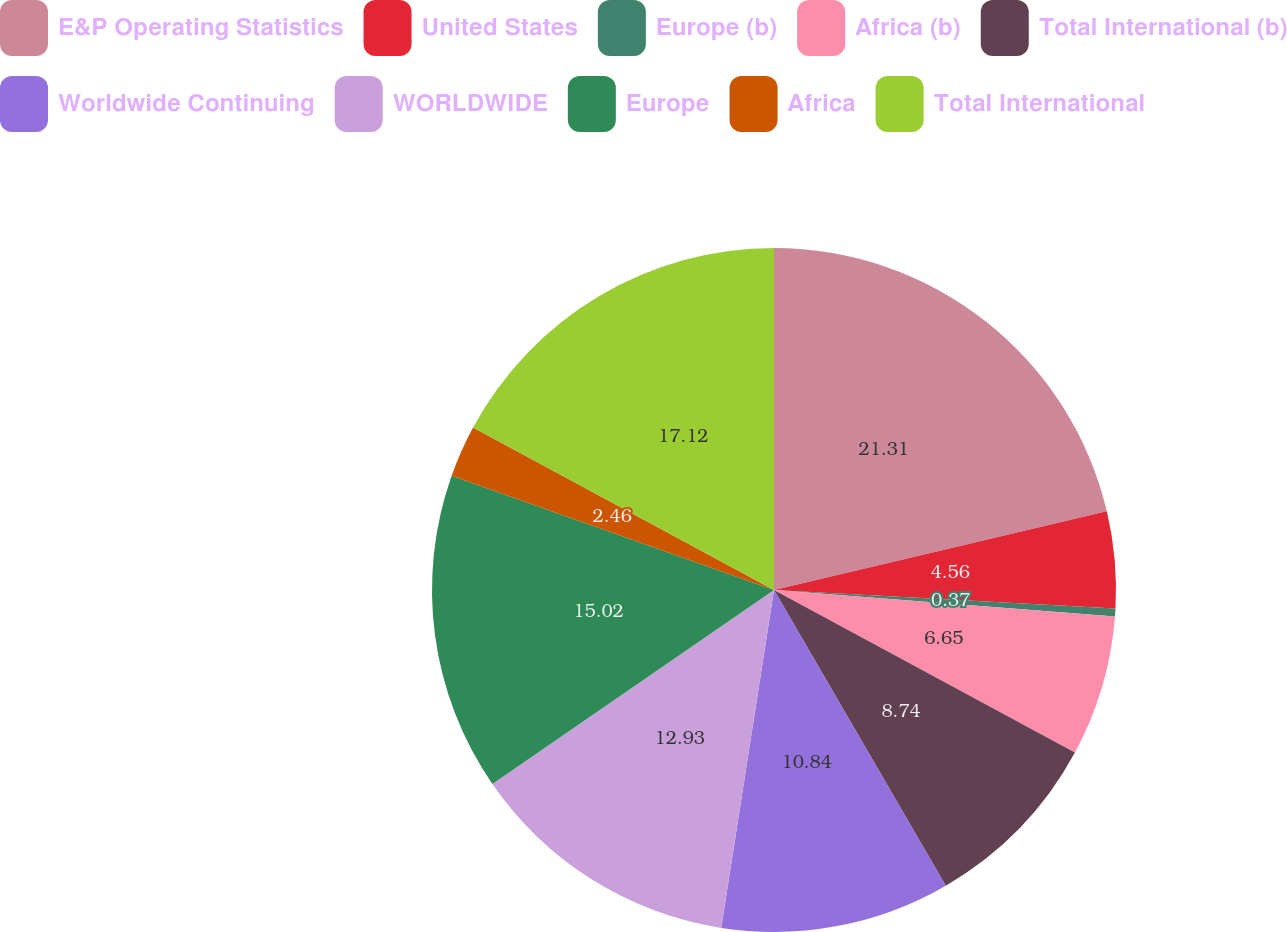Convert chart to OTSL. <chart><loc_0><loc_0><loc_500><loc_500><pie_chart><fcel>E&P Operating Statistics<fcel>United States<fcel>Europe (b)<fcel>Africa (b)<fcel>Total International (b)<fcel>Worldwide Continuing<fcel>WORLDWIDE<fcel>Europe<fcel>Africa<fcel>Total International<nl><fcel>21.3%<fcel>4.56%<fcel>0.37%<fcel>6.65%<fcel>8.74%<fcel>10.84%<fcel>12.93%<fcel>15.02%<fcel>2.46%<fcel>17.12%<nl></chart> 